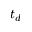Convert formula to latex. <formula><loc_0><loc_0><loc_500><loc_500>t _ { d }</formula> 